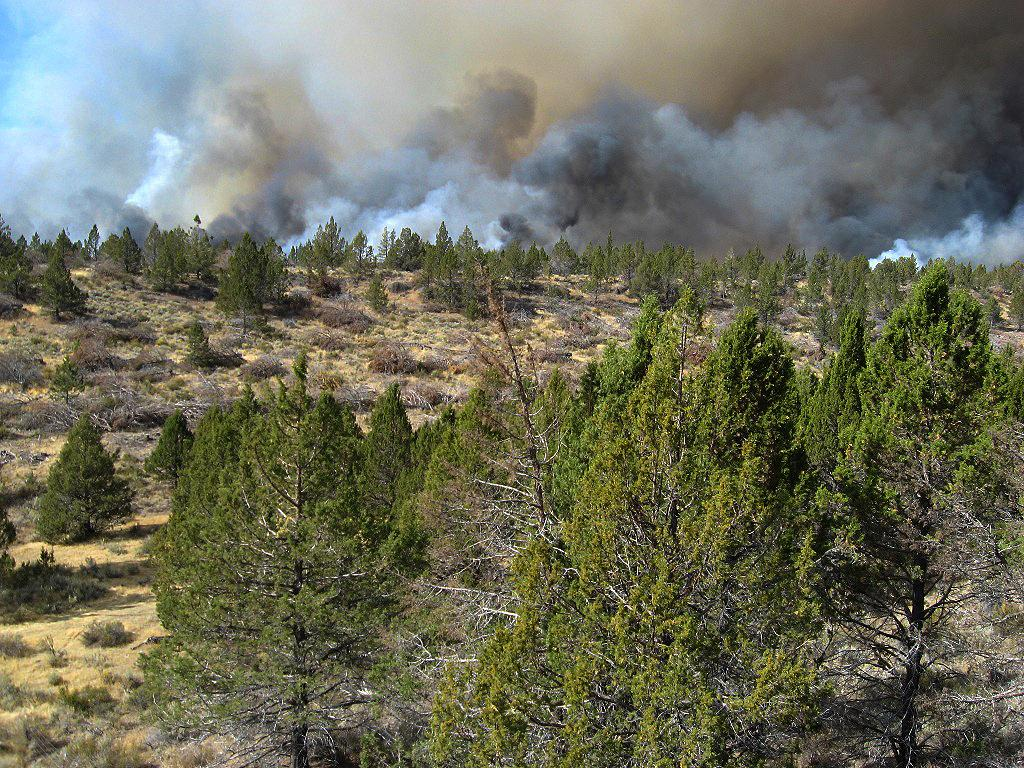What type of natural vegetation is visible in the image? There are many trees in the image. What is visible in the sky in the image? The sky is clouded in the image. How many chairs are placed around the sail in the image? There are no chairs or sail present in the image; it features trees and a clouded sky. 